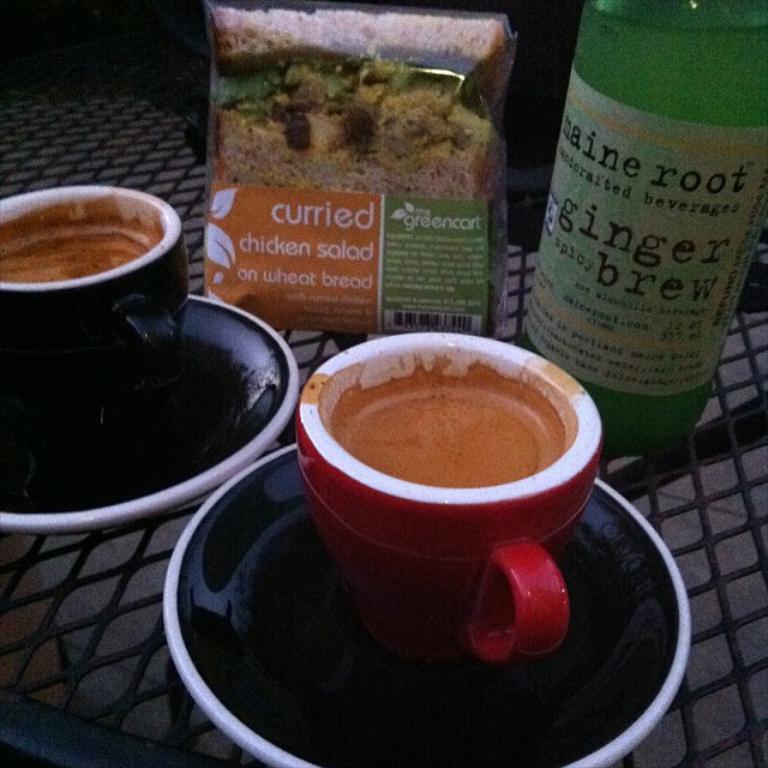Can you describe this image briefly? Here in this picture we can see a couple of cups filled with something present on a saucer and we can also see a bottle and a packet all present on the table. 